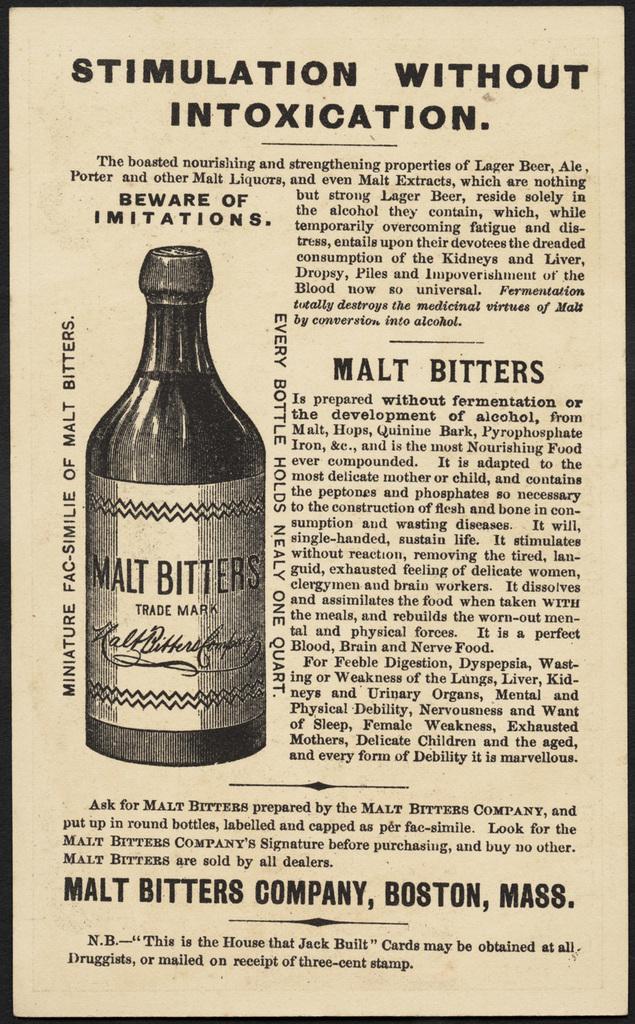What type of bitters is this an advertisement for?
Your response must be concise. Malt. What does this provide stimulation without?
Keep it short and to the point. Intoxication. 